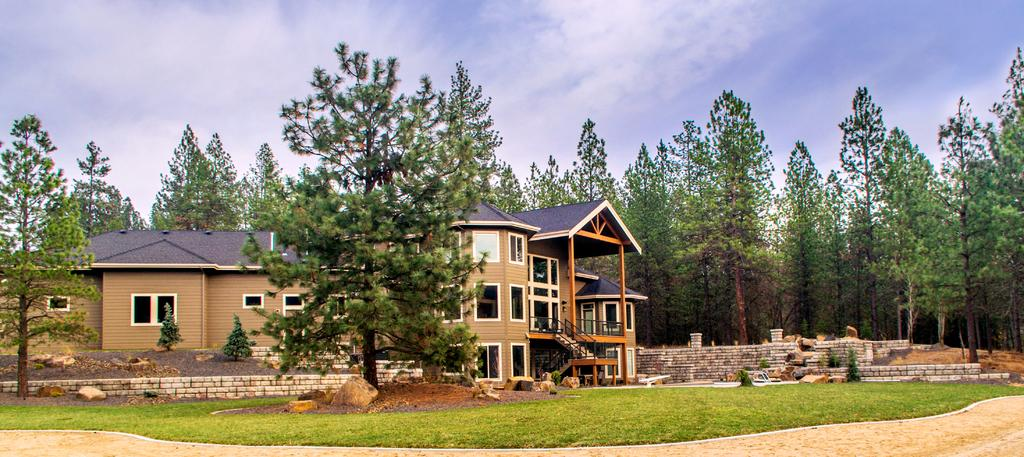What is the main subject of the image? There is a beautiful house in the middle of the image. What type of natural elements can be seen in the image? There are trees in the image. How would you describe the weather in the image? The sky is cloudy in the image. How many pages of the expert's report can be seen in the image? There is no expert's report or pages present in the image. Is there any blood visible in the image? There is no blood visible in the image. 